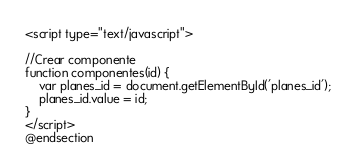Convert code to text. <code><loc_0><loc_0><loc_500><loc_500><_PHP_><script type="text/javascript">

//Crear componente
function componentes(id) {
    var planes_id = document.getElementById('planes_id');
    planes_id.value = id;                
}
</script>
@endsection
</code> 